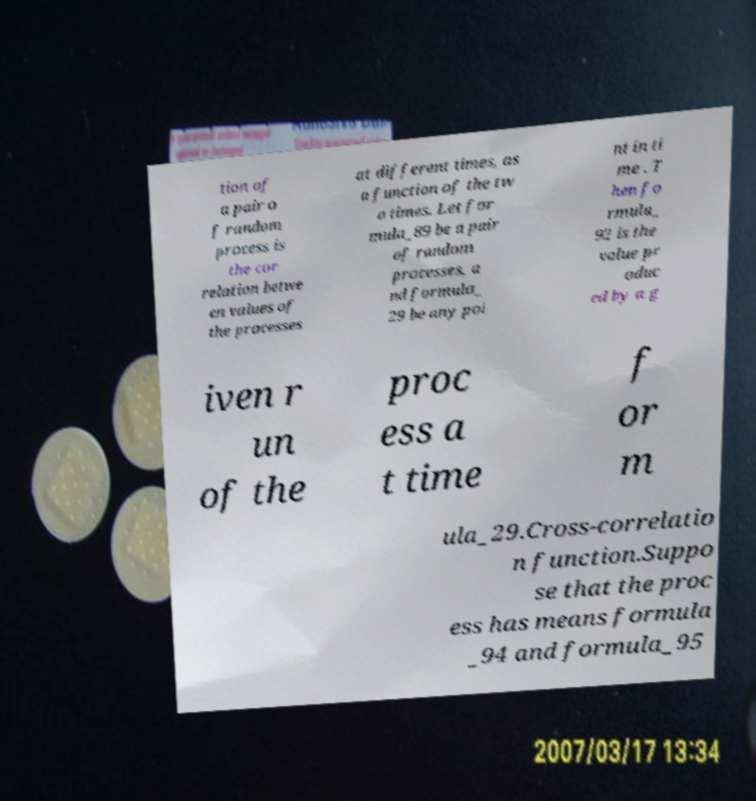What messages or text are displayed in this image? I need them in a readable, typed format. tion of a pair o f random process is the cor relation betwe en values of the processes at different times, as a function of the tw o times. Let for mula_89 be a pair of random processes, a nd formula_ 29 be any poi nt in ti me . T hen fo rmula_ 92 is the value pr oduc ed by a g iven r un of the proc ess a t time f or m ula_29.Cross-correlatio n function.Suppo se that the proc ess has means formula _94 and formula_95 